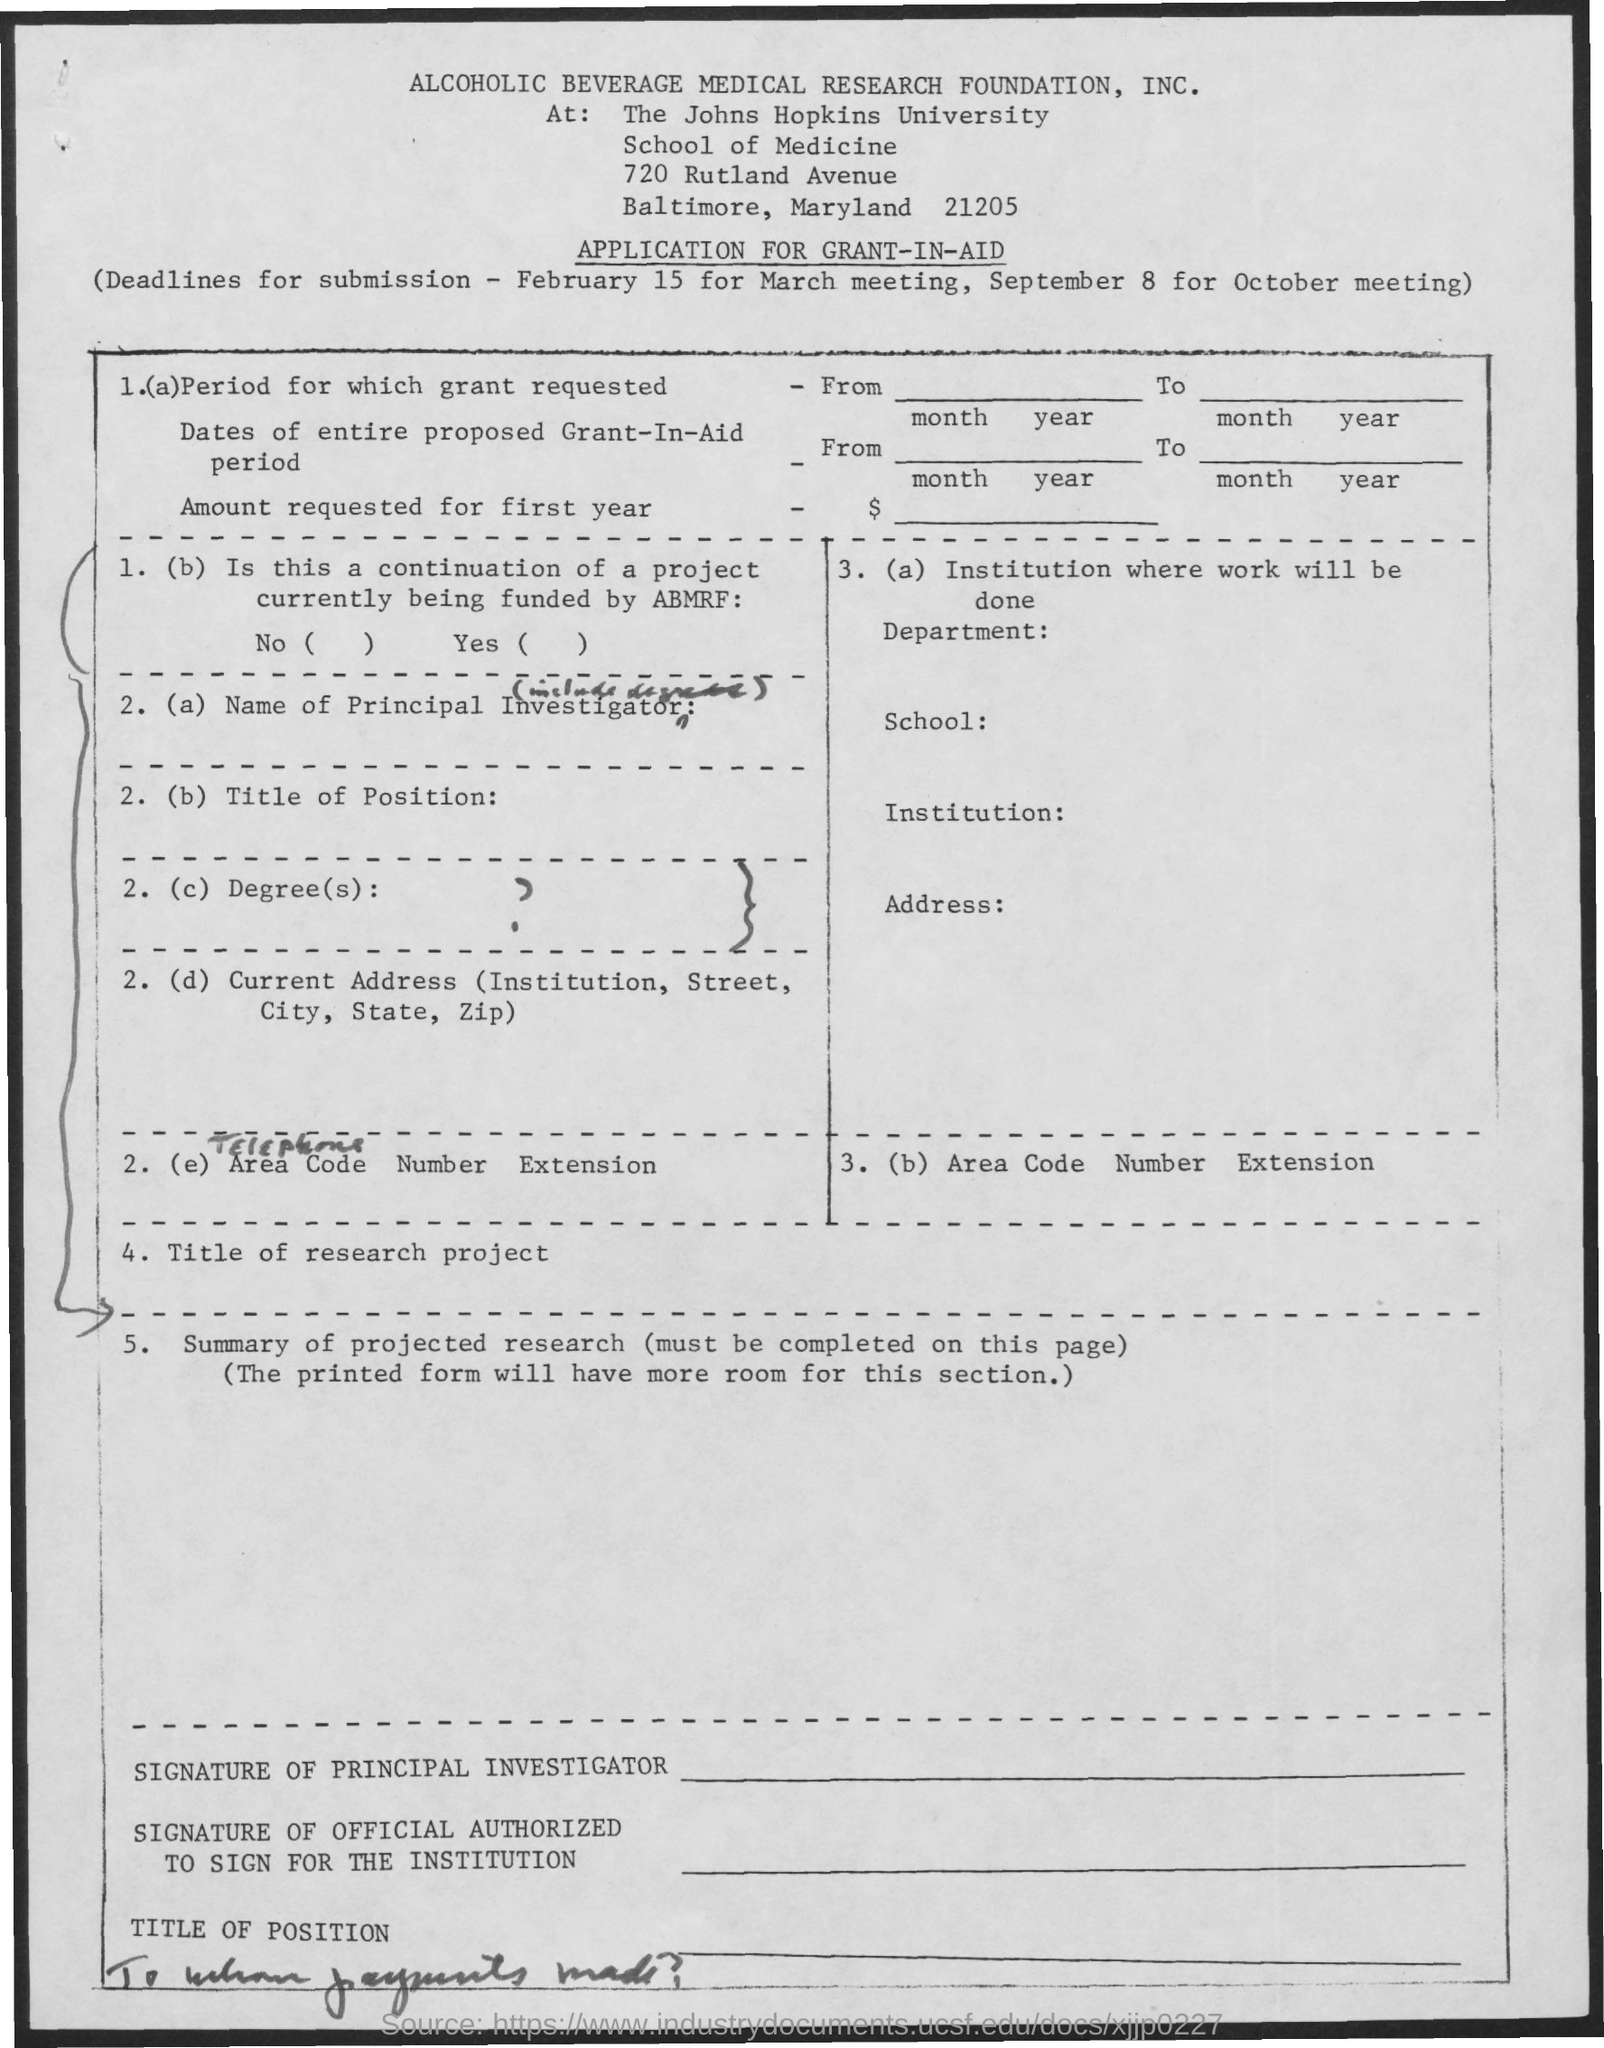Point out several critical features in this image. The deadline for the submission of items for the October meeting is on September 8. This application is for a grant-in-aid. The deadline for submission for the March meeting is February 15. 